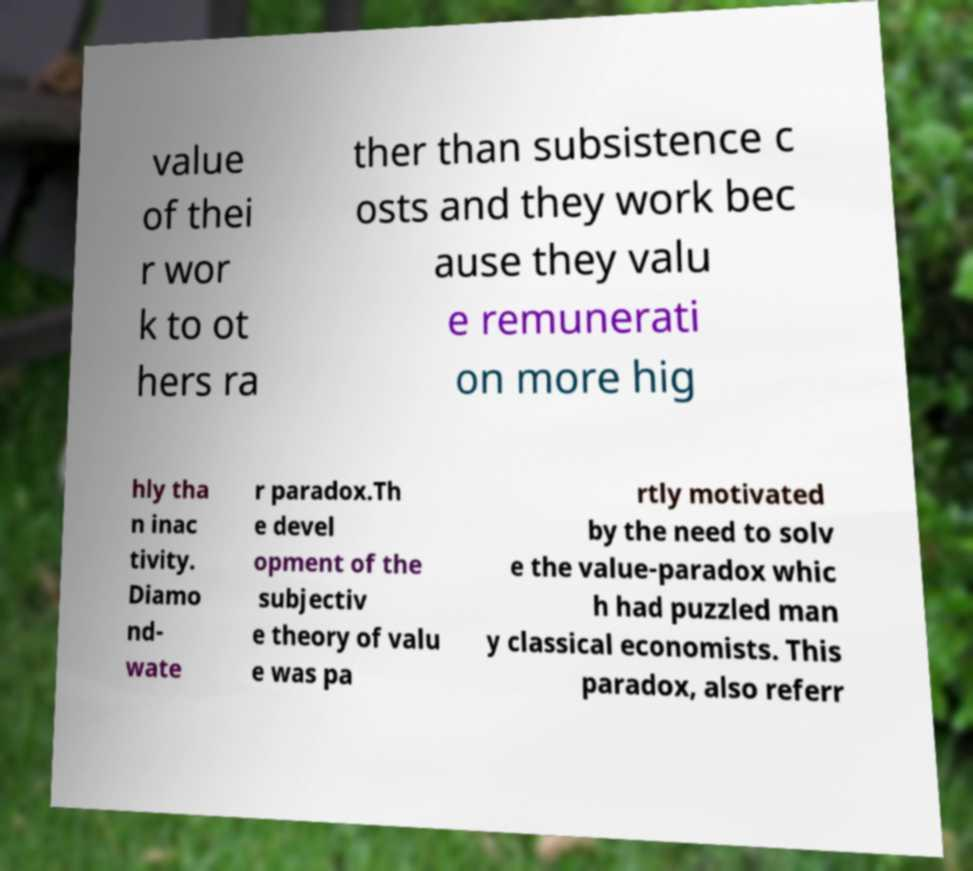Can you accurately transcribe the text from the provided image for me? value of thei r wor k to ot hers ra ther than subsistence c osts and they work bec ause they valu e remunerati on more hig hly tha n inac tivity. Diamo nd- wate r paradox.Th e devel opment of the subjectiv e theory of valu e was pa rtly motivated by the need to solv e the value-paradox whic h had puzzled man y classical economists. This paradox, also referr 